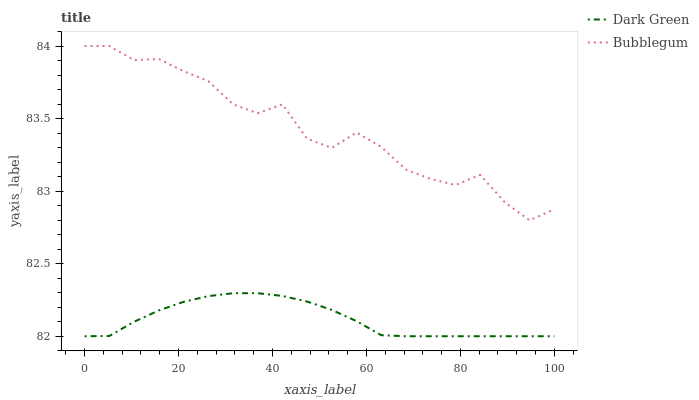Does Dark Green have the maximum area under the curve?
Answer yes or no. No. Is Dark Green the roughest?
Answer yes or no. No. Does Dark Green have the highest value?
Answer yes or no. No. Is Dark Green less than Bubblegum?
Answer yes or no. Yes. Is Bubblegum greater than Dark Green?
Answer yes or no. Yes. Does Dark Green intersect Bubblegum?
Answer yes or no. No. 